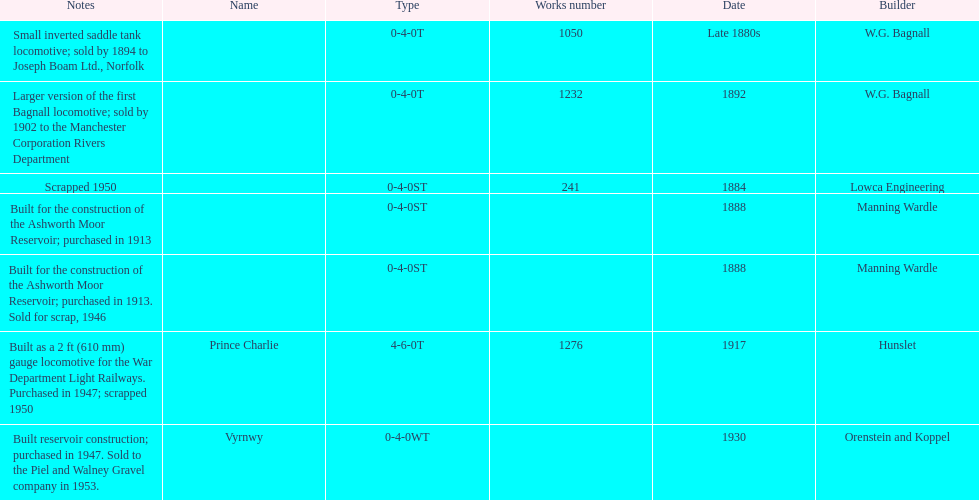How many locomotives were built before the 1900s? 5. 